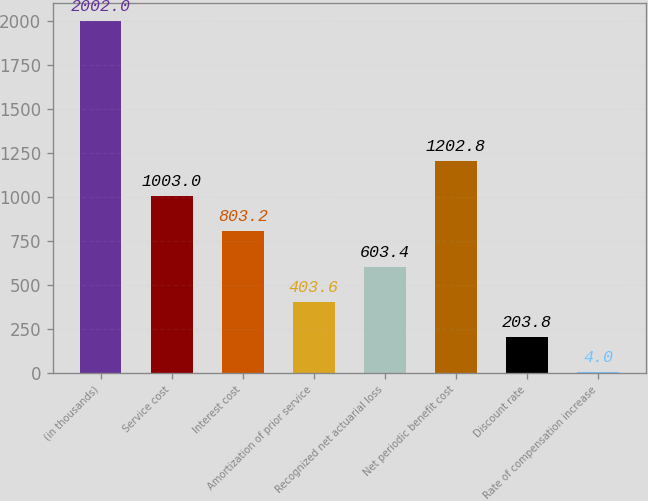Convert chart. <chart><loc_0><loc_0><loc_500><loc_500><bar_chart><fcel>(in thousands)<fcel>Service cost<fcel>Interest cost<fcel>Amortization of prior service<fcel>Recognized net actuarial loss<fcel>Net periodic benefit cost<fcel>Discount rate<fcel>Rate of compensation increase<nl><fcel>2002<fcel>1003<fcel>803.2<fcel>403.6<fcel>603.4<fcel>1202.8<fcel>203.8<fcel>4<nl></chart> 